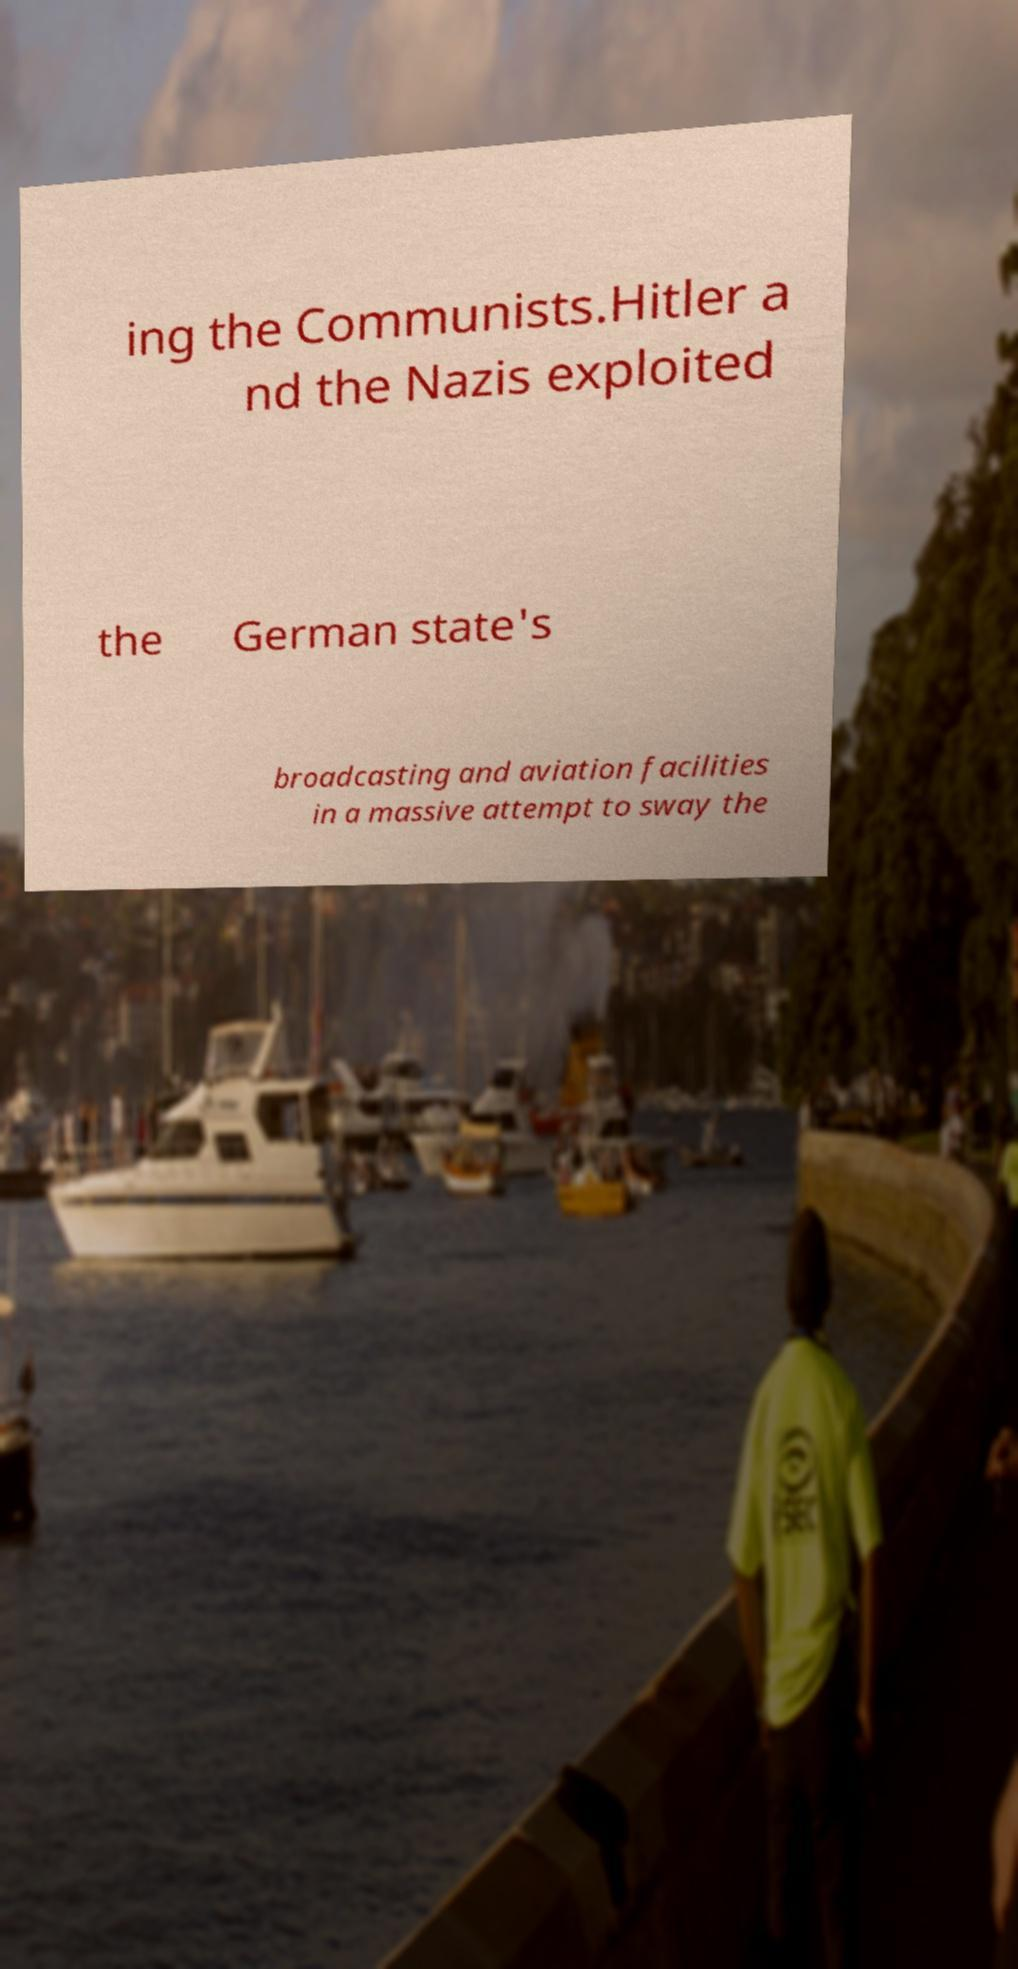I need the written content from this picture converted into text. Can you do that? ing the Communists.Hitler a nd the Nazis exploited the German state's broadcasting and aviation facilities in a massive attempt to sway the 